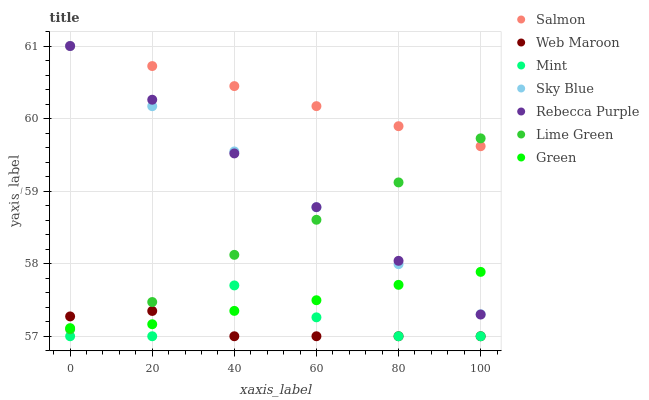Does Web Maroon have the minimum area under the curve?
Answer yes or no. Yes. Does Salmon have the maximum area under the curve?
Answer yes or no. Yes. Does Green have the minimum area under the curve?
Answer yes or no. No. Does Green have the maximum area under the curve?
Answer yes or no. No. Is Rebecca Purple the smoothest?
Answer yes or no. Yes. Is Mint the roughest?
Answer yes or no. Yes. Is Web Maroon the smoothest?
Answer yes or no. No. Is Web Maroon the roughest?
Answer yes or no. No. Does Web Maroon have the lowest value?
Answer yes or no. Yes. Does Green have the lowest value?
Answer yes or no. No. Does Sky Blue have the highest value?
Answer yes or no. Yes. Does Green have the highest value?
Answer yes or no. No. Is Web Maroon less than Rebecca Purple?
Answer yes or no. Yes. Is Salmon greater than Mint?
Answer yes or no. Yes. Does Sky Blue intersect Green?
Answer yes or no. Yes. Is Sky Blue less than Green?
Answer yes or no. No. Is Sky Blue greater than Green?
Answer yes or no. No. Does Web Maroon intersect Rebecca Purple?
Answer yes or no. No. 